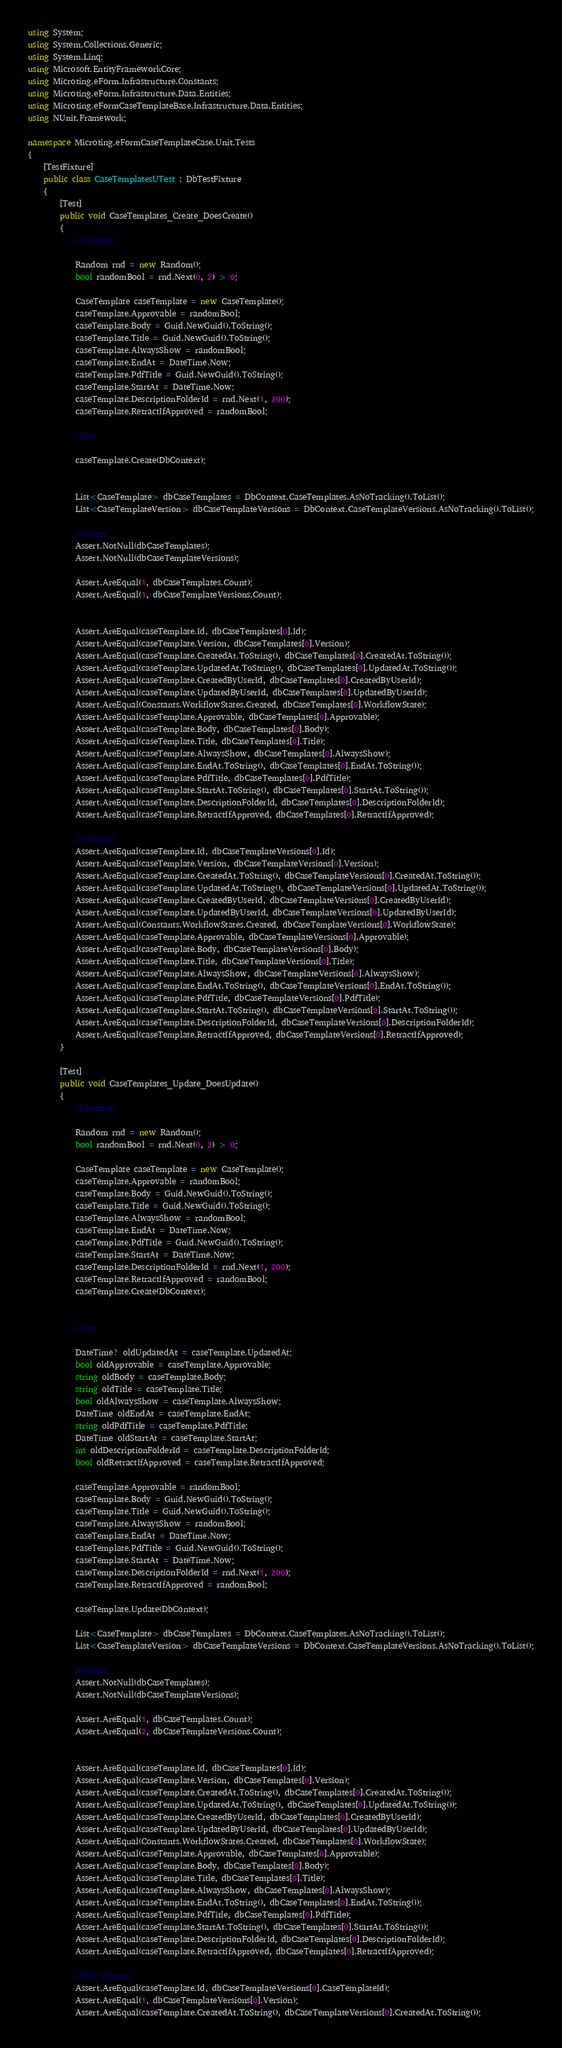Convert code to text. <code><loc_0><loc_0><loc_500><loc_500><_C#_>using System;
using System.Collections.Generic;
using System.Linq;
using Microsoft.EntityFrameworkCore;
using Microting.eForm.Infrastructure.Constants;
using Microting.eForm.Infrastructure.Data.Entities;
using Microting.eFormCaseTemplateBase.Infrastructure.Data.Entities;
using NUnit.Framework;

namespace Microting.eFormCaseTemplateCase.Unit.Tests
{
    [TestFixture]
    public class CaseTemplatesUTest : DbTestFixture
    {
        [Test]
        public void CaseTemplates_Create_DoesCreate()
        {
            //Arrange
            
            Random rnd = new Random();
            bool randomBool = rnd.Next(0, 2) > 0;
            
            CaseTemplate caseTemplate = new CaseTemplate();
            caseTemplate.Approvable = randomBool;
            caseTemplate.Body = Guid.NewGuid().ToString();
            caseTemplate.Title = Guid.NewGuid().ToString();
            caseTemplate.AlwaysShow = randomBool;
            caseTemplate.EndAt = DateTime.Now;
            caseTemplate.PdfTitle = Guid.NewGuid().ToString();
            caseTemplate.StartAt = DateTime.Now;
            caseTemplate.DescriptionFolderId = rnd.Next(1, 200);
            caseTemplate.RetractIfApproved = randomBool;
            
            //Act
            
            caseTemplate.Create(DbContext);
            

            List<CaseTemplate> dbCaseTemplates = DbContext.CaseTemplates.AsNoTracking().ToList();
            List<CaseTemplateVersion> dbCaseTemplateVersions = DbContext.CaseTemplateVersions.AsNoTracking().ToList();
            
            //Assert
            Assert.NotNull(dbCaseTemplates);
            Assert.NotNull(dbCaseTemplateVersions);
            
            Assert.AreEqual(1, dbCaseTemplates.Count);
            Assert.AreEqual(1, dbCaseTemplateVersions.Count);
            
            
            Assert.AreEqual(caseTemplate.Id, dbCaseTemplates[0].Id);
            Assert.AreEqual(caseTemplate.Version, dbCaseTemplates[0].Version);
            Assert.AreEqual(caseTemplate.CreatedAt.ToString(), dbCaseTemplates[0].CreatedAt.ToString());
            Assert.AreEqual(caseTemplate.UpdatedAt.ToString(), dbCaseTemplates[0].UpdatedAt.ToString());
            Assert.AreEqual(caseTemplate.CreatedByUserId, dbCaseTemplates[0].CreatedByUserId);
            Assert.AreEqual(caseTemplate.UpdatedByUserId, dbCaseTemplates[0].UpdatedByUserId);
            Assert.AreEqual(Constants.WorkflowStates.Created, dbCaseTemplates[0].WorkflowState);
            Assert.AreEqual(caseTemplate.Approvable, dbCaseTemplates[0].Approvable);
            Assert.AreEqual(caseTemplate.Body, dbCaseTemplates[0].Body);
            Assert.AreEqual(caseTemplate.Title, dbCaseTemplates[0].Title);
            Assert.AreEqual(caseTemplate.AlwaysShow, dbCaseTemplates[0].AlwaysShow);
            Assert.AreEqual(caseTemplate.EndAt.ToString(), dbCaseTemplates[0].EndAt.ToString());
            Assert.AreEqual(caseTemplate.PdfTitle, dbCaseTemplates[0].PdfTitle);
            Assert.AreEqual(caseTemplate.StartAt.ToString(), dbCaseTemplates[0].StartAt.ToString());
            Assert.AreEqual(caseTemplate.DescriptionFolderId, dbCaseTemplates[0].DescriptionFolderId);
            Assert.AreEqual(caseTemplate.RetractIfApproved, dbCaseTemplates[0].RetractIfApproved);

            //Versions
            Assert.AreEqual(caseTemplate.Id, dbCaseTemplateVersions[0].Id);
            Assert.AreEqual(caseTemplate.Version, dbCaseTemplateVersions[0].Version);
            Assert.AreEqual(caseTemplate.CreatedAt.ToString(), dbCaseTemplateVersions[0].CreatedAt.ToString());
            Assert.AreEqual(caseTemplate.UpdatedAt.ToString(), dbCaseTemplateVersions[0].UpdatedAt.ToString());
            Assert.AreEqual(caseTemplate.CreatedByUserId, dbCaseTemplateVersions[0].CreatedByUserId);
            Assert.AreEqual(caseTemplate.UpdatedByUserId, dbCaseTemplateVersions[0].UpdatedByUserId);
            Assert.AreEqual(Constants.WorkflowStates.Created, dbCaseTemplateVersions[0].WorkflowState);
            Assert.AreEqual(caseTemplate.Approvable, dbCaseTemplateVersions[0].Approvable);
            Assert.AreEqual(caseTemplate.Body, dbCaseTemplateVersions[0].Body);
            Assert.AreEqual(caseTemplate.Title, dbCaseTemplateVersions[0].Title);
            Assert.AreEqual(caseTemplate.AlwaysShow, dbCaseTemplateVersions[0].AlwaysShow);
            Assert.AreEqual(caseTemplate.EndAt.ToString(), dbCaseTemplateVersions[0].EndAt.ToString());
            Assert.AreEqual(caseTemplate.PdfTitle, dbCaseTemplateVersions[0].PdfTitle);
            Assert.AreEqual(caseTemplate.StartAt.ToString(), dbCaseTemplateVersions[0].StartAt.ToString());
            Assert.AreEqual(caseTemplate.DescriptionFolderId, dbCaseTemplateVersions[0].DescriptionFolderId);
            Assert.AreEqual(caseTemplate.RetractIfApproved, dbCaseTemplateVersions[0].RetractIfApproved);
        }

        [Test]
        public void CaseTemplates_Update_DoesUpdate()
        {
            //Arrange
            
            Random rnd = new Random();
            bool randomBool = rnd.Next(0, 2) > 0;
            
            CaseTemplate caseTemplate = new CaseTemplate();
            caseTemplate.Approvable = randomBool;
            caseTemplate.Body = Guid.NewGuid().ToString();
            caseTemplate.Title = Guid.NewGuid().ToString();
            caseTemplate.AlwaysShow = randomBool;
            caseTemplate.EndAt = DateTime.Now;
            caseTemplate.PdfTitle = Guid.NewGuid().ToString();
            caseTemplate.StartAt = DateTime.Now;
            caseTemplate.DescriptionFolderId = rnd.Next(1, 200);
            caseTemplate.RetractIfApproved = randomBool;
            caseTemplate.Create(DbContext);

            
            //Act

            DateTime? oldUpdatedAt = caseTemplate.UpdatedAt;
            bool oldApprovable = caseTemplate.Approvable;
            string oldBody = caseTemplate.Body;
            string oldTitle = caseTemplate.Title;
            bool oldAlwaysShow = caseTemplate.AlwaysShow;
            DateTime oldEndAt = caseTemplate.EndAt;
            string oldPdfTitle = caseTemplate.PdfTitle;
            DateTime oldStartAt = caseTemplate.StartAt;
            int oldDescriptionFolderId = caseTemplate.DescriptionFolderId;
            bool oldRetractIfApproved = caseTemplate.RetractIfApproved;
            
            caseTemplate.Approvable = randomBool;
            caseTemplate.Body = Guid.NewGuid().ToString();
            caseTemplate.Title = Guid.NewGuid().ToString();
            caseTemplate.AlwaysShow = randomBool;
            caseTemplate.EndAt = DateTime.Now;
            caseTemplate.PdfTitle = Guid.NewGuid().ToString();
            caseTemplate.StartAt = DateTime.Now;
            caseTemplate.DescriptionFolderId = rnd.Next(1, 200);
            caseTemplate.RetractIfApproved = randomBool;

            caseTemplate.Update(DbContext);

            List<CaseTemplate> dbCaseTemplates = DbContext.CaseTemplates.AsNoTracking().ToList();
            List<CaseTemplateVersion> dbCaseTemplateVersions = DbContext.CaseTemplateVersions.AsNoTracking().ToList();
            
            //Assert
            Assert.NotNull(dbCaseTemplates);
            Assert.NotNull(dbCaseTemplateVersions);
            
            Assert.AreEqual(1, dbCaseTemplates.Count);
            Assert.AreEqual(2, dbCaseTemplateVersions.Count);
            
            
            Assert.AreEqual(caseTemplate.Id, dbCaseTemplates[0].Id);
            Assert.AreEqual(caseTemplate.Version, dbCaseTemplates[0].Version);
            Assert.AreEqual(caseTemplate.CreatedAt.ToString(), dbCaseTemplates[0].CreatedAt.ToString());
            Assert.AreEqual(caseTemplate.UpdatedAt.ToString(), dbCaseTemplates[0].UpdatedAt.ToString());
            Assert.AreEqual(caseTemplate.CreatedByUserId, dbCaseTemplates[0].CreatedByUserId);
            Assert.AreEqual(caseTemplate.UpdatedByUserId, dbCaseTemplates[0].UpdatedByUserId);
            Assert.AreEqual(Constants.WorkflowStates.Created, dbCaseTemplates[0].WorkflowState);
            Assert.AreEqual(caseTemplate.Approvable, dbCaseTemplates[0].Approvable);
            Assert.AreEqual(caseTemplate.Body, dbCaseTemplates[0].Body);
            Assert.AreEqual(caseTemplate.Title, dbCaseTemplates[0].Title);
            Assert.AreEqual(caseTemplate.AlwaysShow, dbCaseTemplates[0].AlwaysShow);
            Assert.AreEqual(caseTemplate.EndAt.ToString(), dbCaseTemplates[0].EndAt.ToString());
            Assert.AreEqual(caseTemplate.PdfTitle, dbCaseTemplates[0].PdfTitle);
            Assert.AreEqual(caseTemplate.StartAt.ToString(), dbCaseTemplates[0].StartAt.ToString());
            Assert.AreEqual(caseTemplate.DescriptionFolderId, dbCaseTemplates[0].DescriptionFolderId);
            Assert.AreEqual(caseTemplate.RetractIfApproved, dbCaseTemplates[0].RetractIfApproved);

            //Old Version
            Assert.AreEqual(caseTemplate.Id, dbCaseTemplateVersions[0].CaseTemplateId);
            Assert.AreEqual(1, dbCaseTemplateVersions[0].Version);
            Assert.AreEqual(caseTemplate.CreatedAt.ToString(), dbCaseTemplateVersions[0].CreatedAt.ToString());</code> 